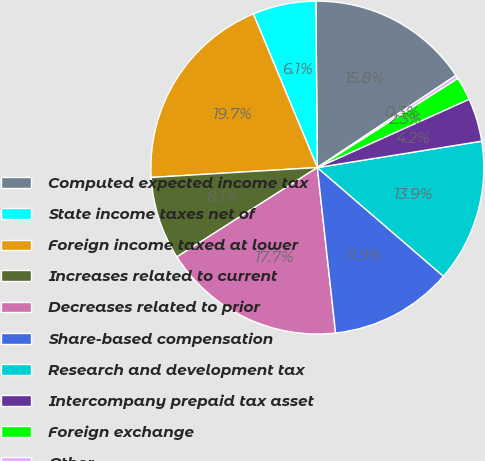Convert chart to OTSL. <chart><loc_0><loc_0><loc_500><loc_500><pie_chart><fcel>Computed expected income tax<fcel>State income taxes net of<fcel>Foreign income taxed at lower<fcel>Increases related to current<fcel>Decreases related to prior<fcel>Share-based compensation<fcel>Research and development tax<fcel>Intercompany prepaid tax asset<fcel>Foreign exchange<fcel>Other<nl><fcel>15.8%<fcel>6.14%<fcel>19.66%<fcel>8.07%<fcel>17.73%<fcel>11.93%<fcel>13.86%<fcel>4.2%<fcel>2.27%<fcel>0.34%<nl></chart> 